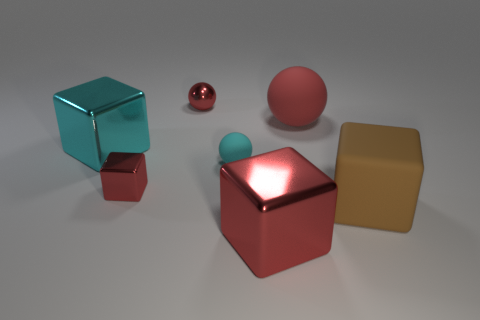There is a small thing behind the large thing on the left side of the small rubber thing; is there a large block right of it?
Offer a very short reply. Yes. There is a big red object that is the same shape as the large brown object; what is it made of?
Your answer should be compact. Metal. There is a red thing that is in front of the big brown rubber thing; what number of blocks are behind it?
Ensure brevity in your answer.  3. There is a metal object that is behind the large thing on the left side of the big red object in front of the small cyan matte thing; how big is it?
Make the answer very short. Small. The shiny cube to the right of the red metal cube behind the large brown rubber thing is what color?
Provide a succinct answer. Red. How many other objects are there of the same material as the big red cube?
Your response must be concise. 3. What number of other objects are the same color as the small matte ball?
Offer a terse response. 1. What material is the large block that is to the left of the big red thing that is in front of the cyan matte sphere?
Your answer should be compact. Metal. Is there a big red thing?
Offer a very short reply. Yes. What is the size of the matte ball that is to the left of the matte sphere that is behind the cyan matte object?
Give a very brief answer. Small. 